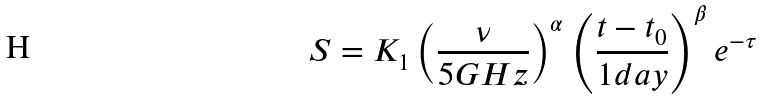Convert formula to latex. <formula><loc_0><loc_0><loc_500><loc_500>S = K _ { 1 } \left ( \frac { \nu } { 5 G H z } \right ) ^ { \alpha } \left ( \frac { t - t _ { 0 } } { 1 d a y } \right ) ^ { \beta } e ^ { - \tau }</formula> 